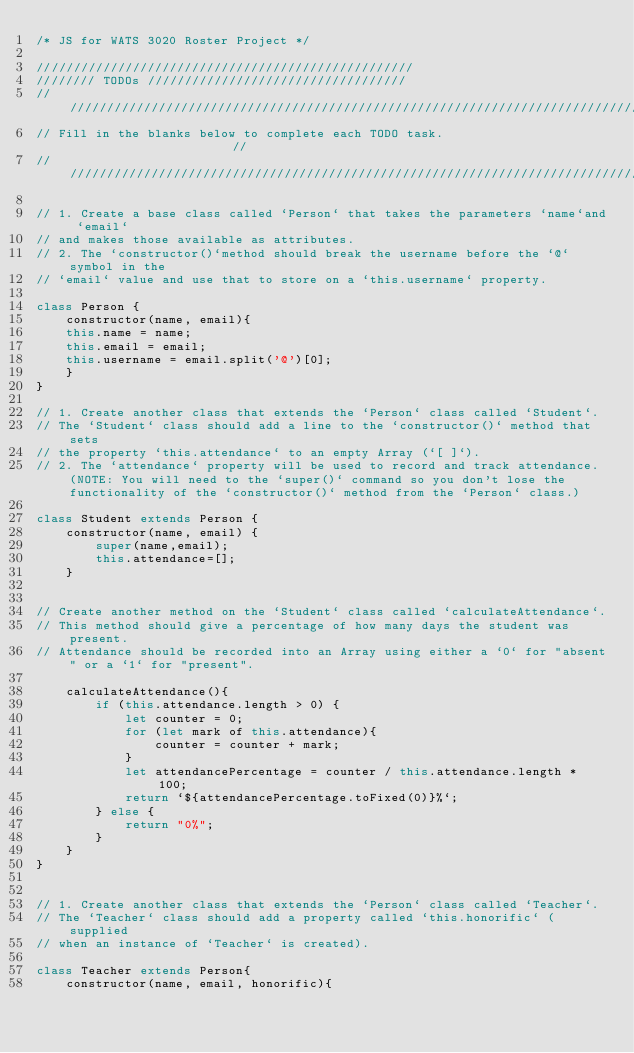<code> <loc_0><loc_0><loc_500><loc_500><_JavaScript_>/* JS for WATS 3020 Roster Project */

///////////////////////////////////////////////////
//////// TODOs ///////////////////////////////////
////////////////////////////////////////////////////////////////////////////////
// Fill in the blanks below to complete each TODO task.                       //
////////////////////////////////////////////////////////////////////////////////

// 1. Create a base class called `Person` that takes the parameters `name`and `email` 
// and makes those available as attributes. 
// 2. The `constructor()`method should break the username before the `@` symbol in the
// `email` value and use that to store on a `this.username` property.

class Person {
    constructor(name, email){
    this.name = name;
    this.email = email;
    this.username = email.split('@')[0];
    }
}

// 1. Create another class that extends the `Person` class called `Student`.
// The `Student` class should add a line to the `constructor()` method that sets
// the property `this.attendance` to an empty Array (`[ ]`). 
// 2. The `attendance` property will be used to record and track attendance. (NOTE: You will need to the `super()` command so you don't lose the functionality of the `constructor()` method from the `Person` class.)

class Student extends Person {
    constructor(name, email) {
        super(name,email);
        this.attendance=[];
    }   


// Create another method on the `Student` class called `calculateAttendance`.
// This method should give a percentage of how many days the student was present.
// Attendance should be recorded into an Array using either a `0` for "absent" or a `1` for "present".

    calculateAttendance(){
        if (this.attendance.length > 0) {
            let counter = 0;
            for (let mark of this.attendance){
                counter = counter + mark;
            }
            let attendancePercentage = counter / this.attendance.length * 100;
            return `${attendancePercentage.toFixed(0)}%`;
        } else {
            return "0%";
        }
    }
}


// 1. Create another class that extends the `Person` class called `Teacher`.
// The `Teacher` class should add a property called `this.honorific` (supplied
// when an instance of `Teacher` is created).

class Teacher extends Person{
    constructor(name, email, honorific){</code> 